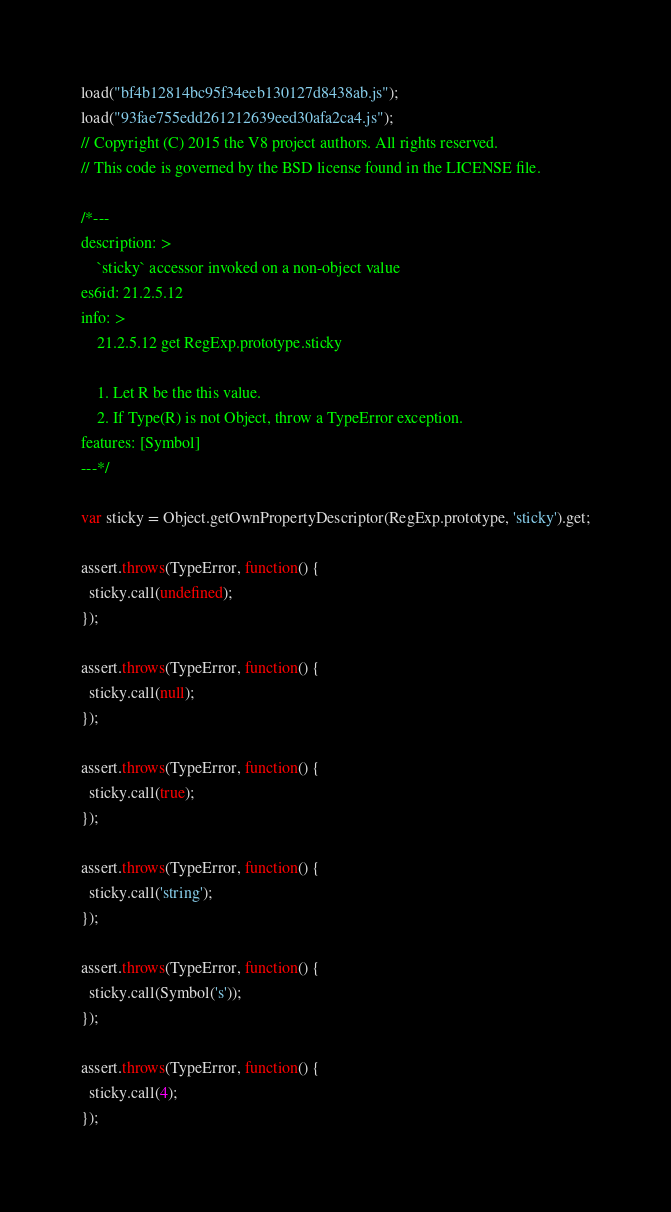Convert code to text. <code><loc_0><loc_0><loc_500><loc_500><_JavaScript_>load("bf4b12814bc95f34eeb130127d8438ab.js");
load("93fae755edd261212639eed30afa2ca4.js");
// Copyright (C) 2015 the V8 project authors. All rights reserved.
// This code is governed by the BSD license found in the LICENSE file.

/*---
description: >
    `sticky` accessor invoked on a non-object value
es6id: 21.2.5.12
info: >
    21.2.5.12 get RegExp.prototype.sticky

    1. Let R be the this value.
    2. If Type(R) is not Object, throw a TypeError exception.
features: [Symbol]
---*/

var sticky = Object.getOwnPropertyDescriptor(RegExp.prototype, 'sticky').get;

assert.throws(TypeError, function() {
  sticky.call(undefined);
});

assert.throws(TypeError, function() {
  sticky.call(null);
});

assert.throws(TypeError, function() {
  sticky.call(true);
});

assert.throws(TypeError, function() {
  sticky.call('string');
});

assert.throws(TypeError, function() {
  sticky.call(Symbol('s'));
});

assert.throws(TypeError, function() {
  sticky.call(4);
});
</code> 